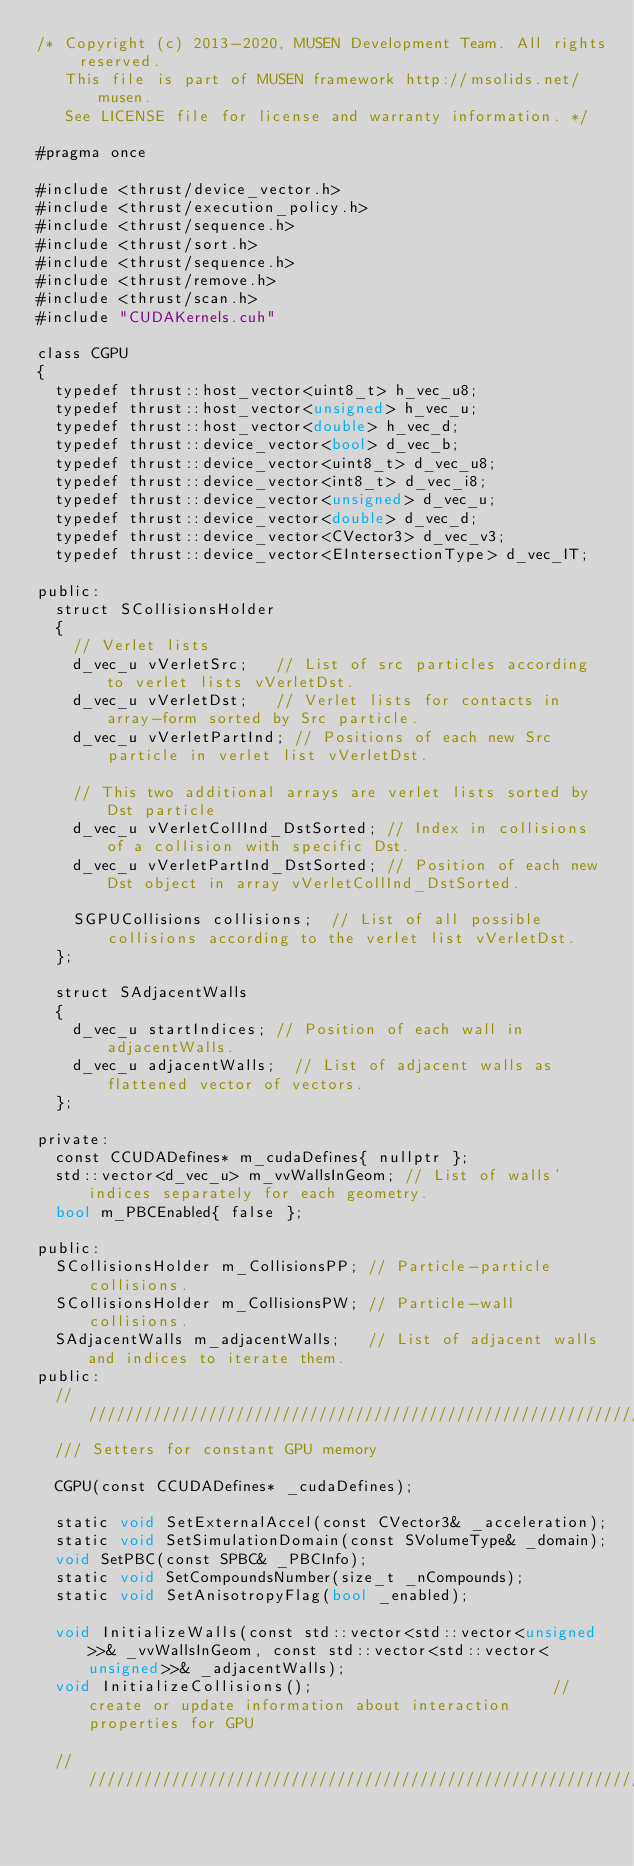<code> <loc_0><loc_0><loc_500><loc_500><_Cuda_>/* Copyright (c) 2013-2020, MUSEN Development Team. All rights reserved.
   This file is part of MUSEN framework http://msolids.net/musen.
   See LICENSE file for license and warranty information. */

#pragma once

#include <thrust/device_vector.h>
#include <thrust/execution_policy.h>
#include <thrust/sequence.h>
#include <thrust/sort.h>
#include <thrust/sequence.h>
#include <thrust/remove.h>
#include <thrust/scan.h>
#include "CUDAKernels.cuh"

class CGPU
{
	typedef thrust::host_vector<uint8_t> h_vec_u8;
	typedef thrust::host_vector<unsigned> h_vec_u;
	typedef thrust::host_vector<double> h_vec_d;
	typedef thrust::device_vector<bool> d_vec_b;
	typedef thrust::device_vector<uint8_t> d_vec_u8;
	typedef thrust::device_vector<int8_t> d_vec_i8;
	typedef thrust::device_vector<unsigned> d_vec_u;
	typedef thrust::device_vector<double> d_vec_d;
	typedef thrust::device_vector<CVector3> d_vec_v3;
	typedef thrust::device_vector<EIntersectionType> d_vec_IT;

public:
	struct SCollisionsHolder
	{
		// Verlet lists
		d_vec_u vVerletSrc;		// List of src particles according to verlet lists vVerletDst.
		d_vec_u vVerletDst;		// Verlet lists for contacts in array-form sorted by Src particle.
		d_vec_u vVerletPartInd;	// Positions of each new Src particle in verlet list vVerletDst.

		// This two additional arrays are verlet lists sorted by Dst particle
		d_vec_u vVerletCollInd_DstSorted; // Index in collisions of a collision with specific Dst.
		d_vec_u vVerletPartInd_DstSorted; // Position of each new Dst object in array vVerletCollInd_DstSorted.

		SGPUCollisions collisions;	// List of all possible collisions according to the verlet list vVerletDst.
	};

	struct SAdjacentWalls
	{
		d_vec_u startIndices;	// Position of each wall in adjacentWalls.
		d_vec_u adjacentWalls;	// List of adjacent walls as flattened vector of vectors.
	};

private:
	const CCUDADefines* m_cudaDefines{ nullptr };
	std::vector<d_vec_u> m_vvWallsInGeom; // List of walls' indices separately for each geometry.
	bool m_PBCEnabled{ false };

public:
	SCollisionsHolder m_CollisionsPP;	// Particle-particle collisions.
	SCollisionsHolder m_CollisionsPW;	// Particle-wall collisions.
	SAdjacentWalls m_adjacentWalls;		// List of adjacent walls and indices to iterate them.
public:
	//////////////////////////////////////////////////////////////////////////
	/// Setters for constant GPU memory

	CGPU(const CCUDADefines* _cudaDefines);

	static void SetExternalAccel(const CVector3& _acceleration);
	static void SetSimulationDomain(const SVolumeType& _domain);
	void SetPBC(const SPBC& _PBCInfo);
	static void SetCompoundsNumber(size_t _nCompounds);
	static void SetAnisotropyFlag(bool _enabled);

	void InitializeWalls(const std::vector<std::vector<unsigned>>& _vvWallsInGeom, const std::vector<std::vector<unsigned>>& _adjacentWalls);
	void InitializeCollisions();													// create or update information about interaction properties for GPU

	//////////////////////////////////////////////////////////////////////////</code> 